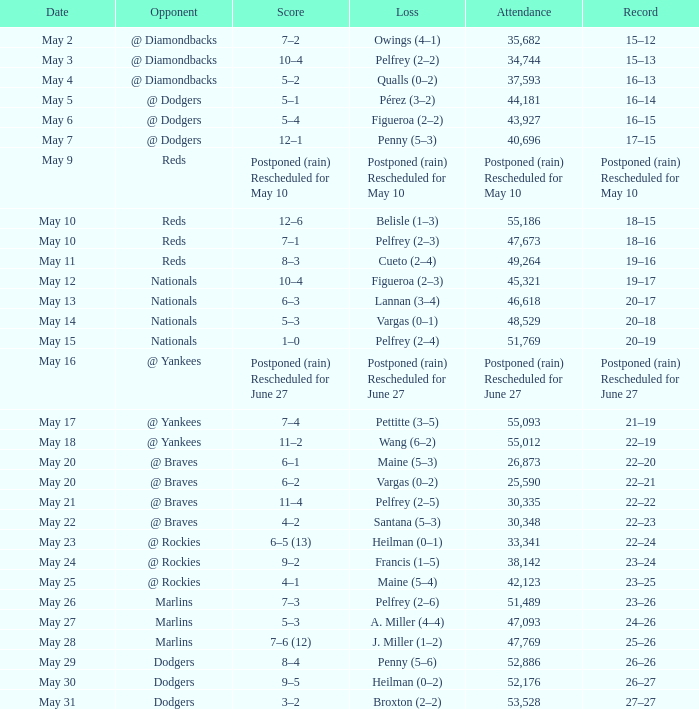When did the 19-16 incident transpire? May 11. 